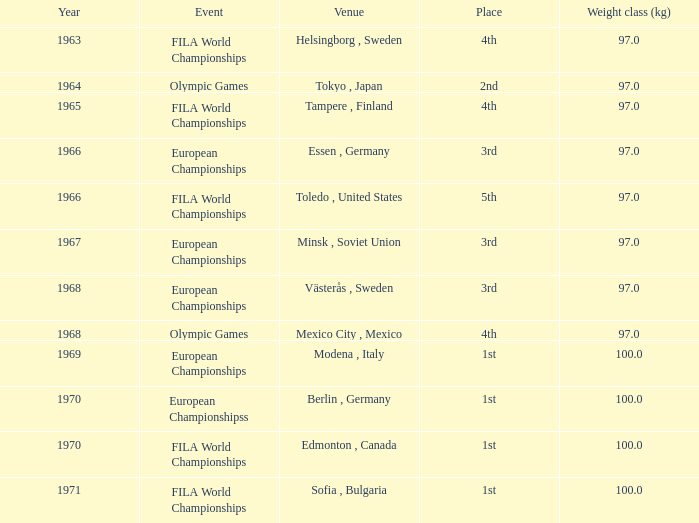What is the highest year that has fila world championships as the event, with toledo, united states as the venue, and a weight class (kg) less than 97? None. 